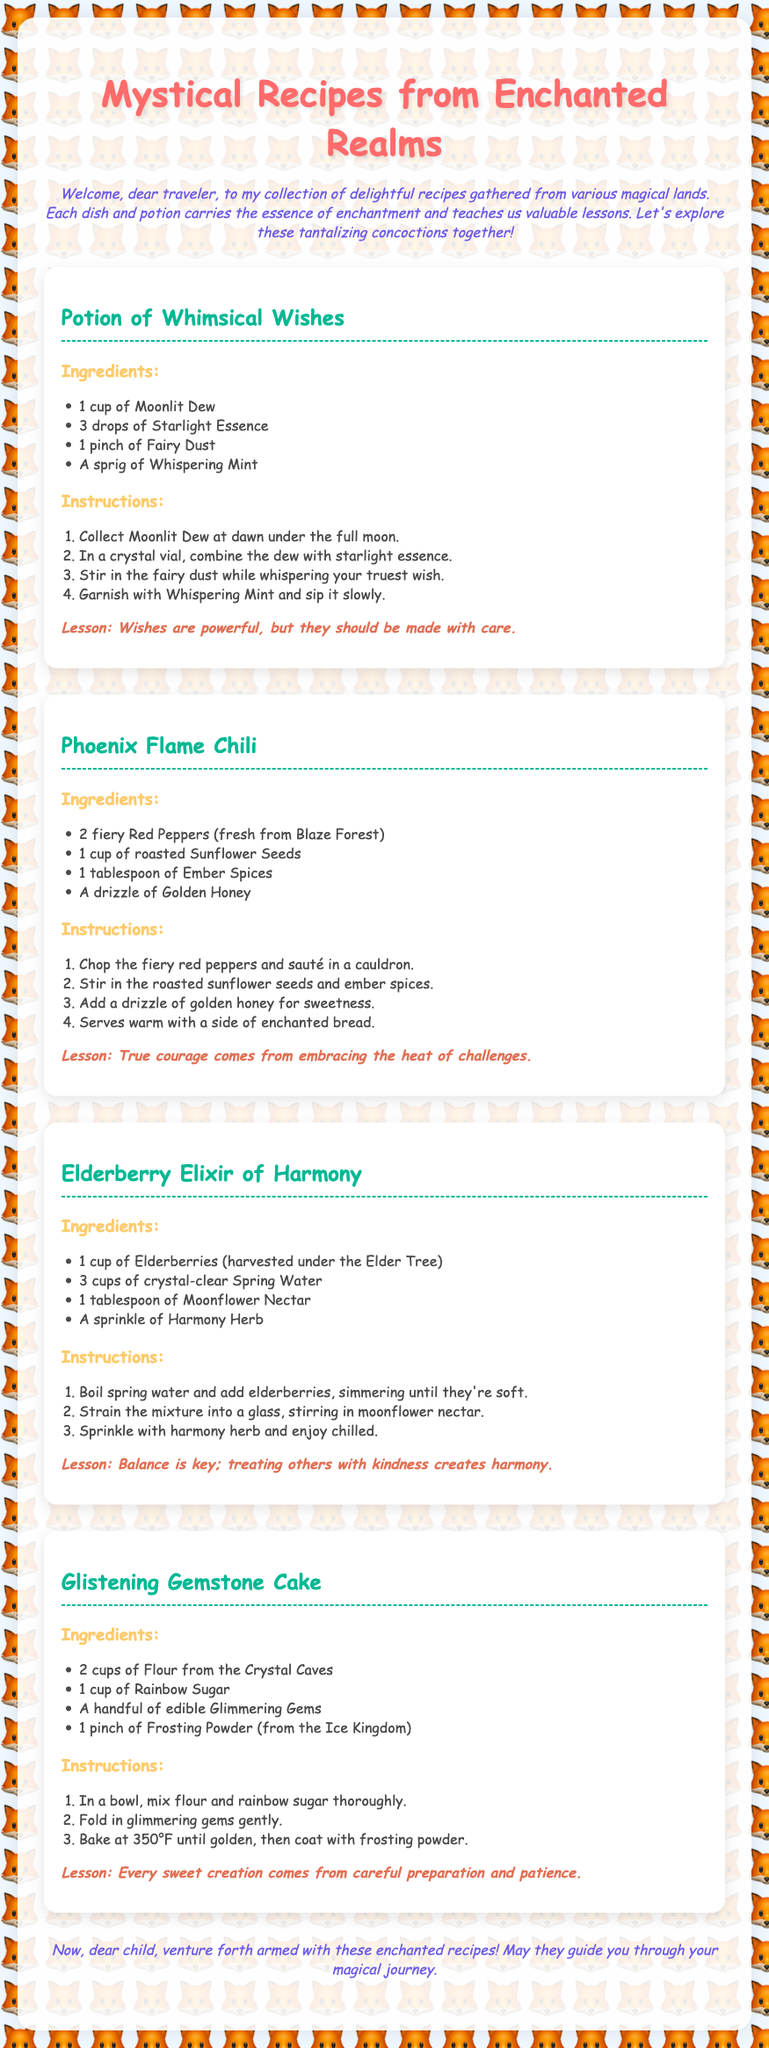What is the title of the document? The title is the main heading at the top of the document.
Answer: Mystical Recipes from Enchanted Realms How many drops of Starlight Essence are needed for the Potion of Whimsical Wishes? This information is found in the ingredients list for the potion.
Answer: 3 drops What lesson does the Phoenix Flame Chili teach? The lesson is stated after the recipe for the chili.
Answer: True courage comes from embracing the heat of challenges Which ingredient is used in the Glistening Gemstone Cake that is from the Ice Kingdom? This ingredient can be found in the ingredients list for the cake.
Answer: Frosting Powder What is the main ingredient used in Elderberry Elixir of Harmony? The main ingredient is the first item listed in the ingredients section of the elixir.
Answer: Elderberries 